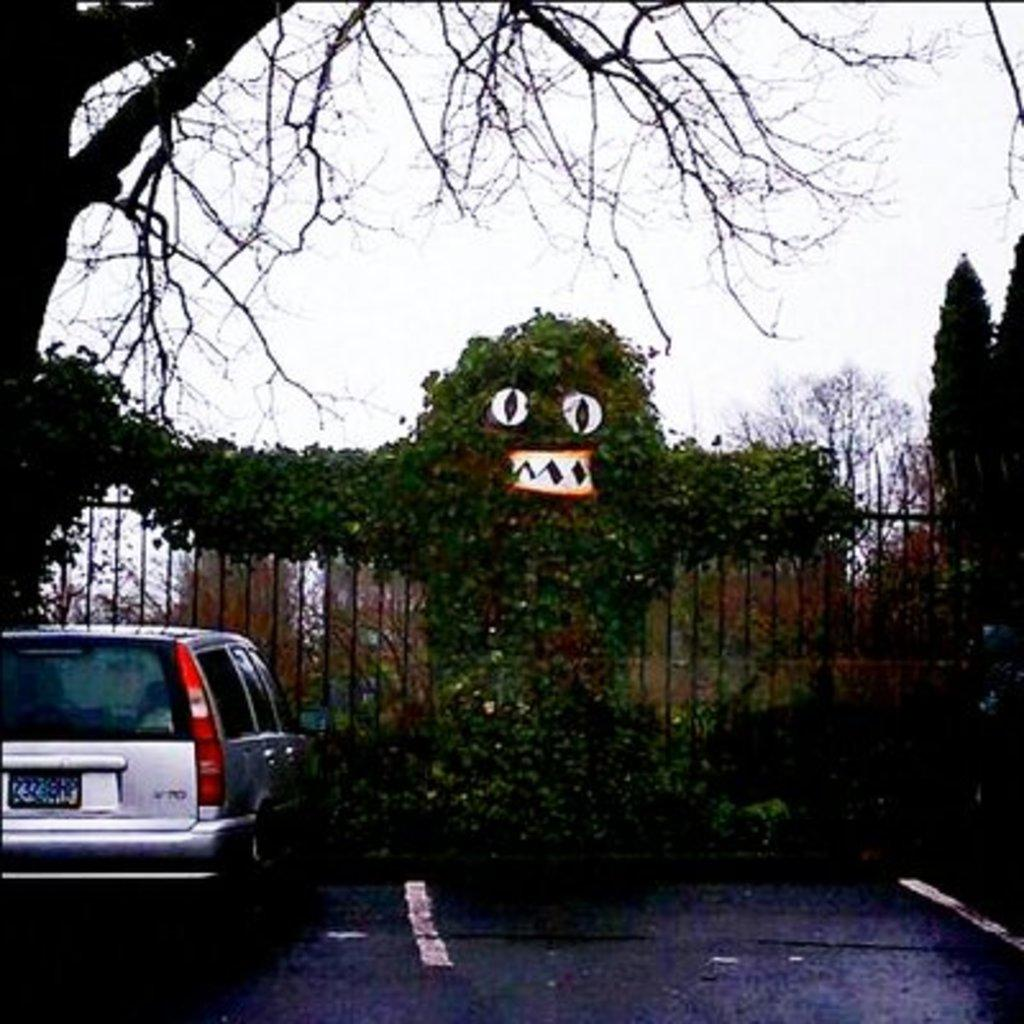What is located on the left side of the image? There is a car on the left side of the image. Where is the car situated? The car is on the road. What can be seen in front of the car? There are trees, metal rods, and plants in front of the car. Where is the umbrella placed in the image? There is no umbrella present in the image. What event is taking place in the image related to a birth? There is no event related to a birth depicted in the image. 